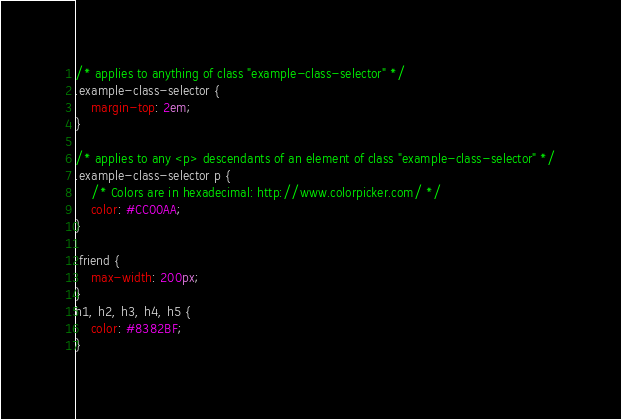<code> <loc_0><loc_0><loc_500><loc_500><_CSS_>/* applies to anything of class "example-class-selector" */
.example-class-selector {
	margin-top: 2em;
}

/* applies to any <p> descendants of an element of class "example-class-selector" */
.example-class-selector p {
	/* Colors are in hexadecimal: http://www.colorpicker.com/ */
	color: #CC00AA;
}

.friend {
	max-width: 200px;
}
h1, h2, h3, h4, h5 {
	color: #8382BF;
}
</code> 